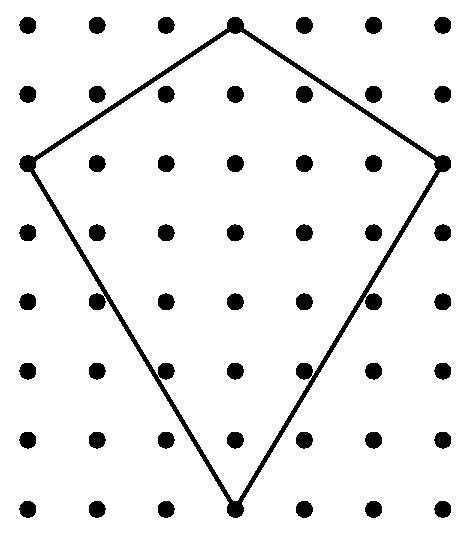Can you describe the geometric shape that is used in the design of this kite? The kite resembles a diamond which is essentially a geometric shape called a rhombus. It is characterized by four sides of equal length with opposite sides parallel and opposite angles equal. 